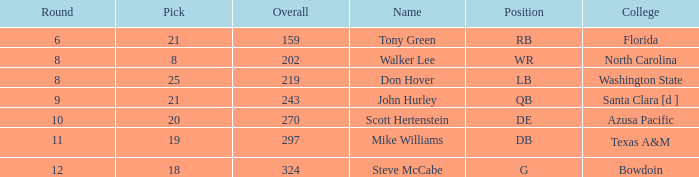How many overalls have a pick greater than 19, with florida as the college? 159.0. 